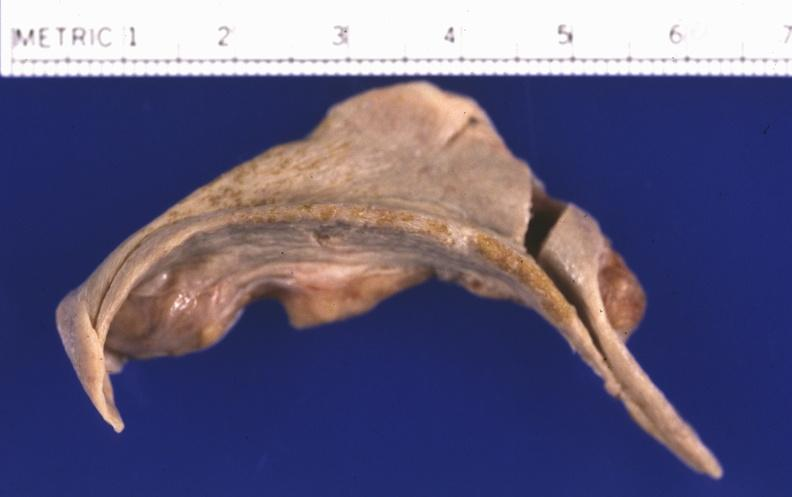does premature coronary disease show spleen, atrophy and fibrosis?
Answer the question using a single word or phrase. No 